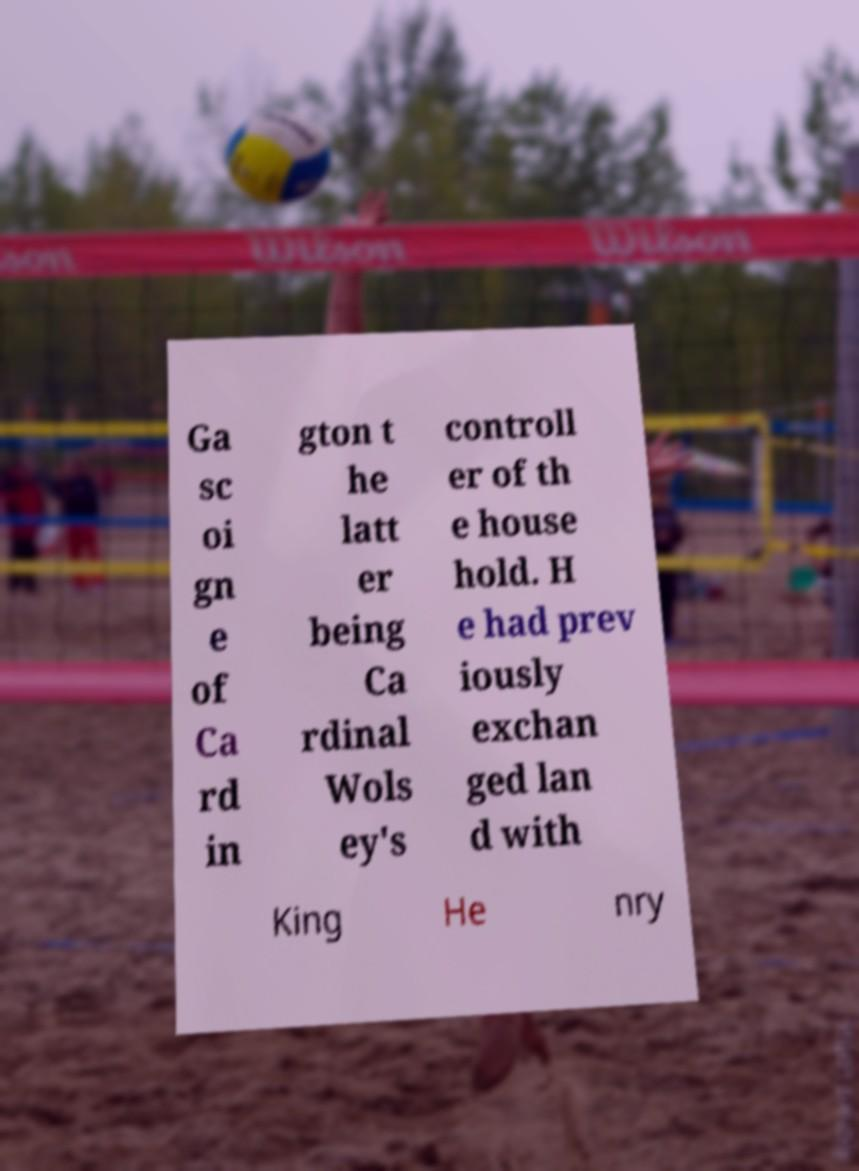Please identify and transcribe the text found in this image. Ga sc oi gn e of Ca rd in gton t he latt er being Ca rdinal Wols ey's controll er of th e house hold. H e had prev iously exchan ged lan d with King He nry 